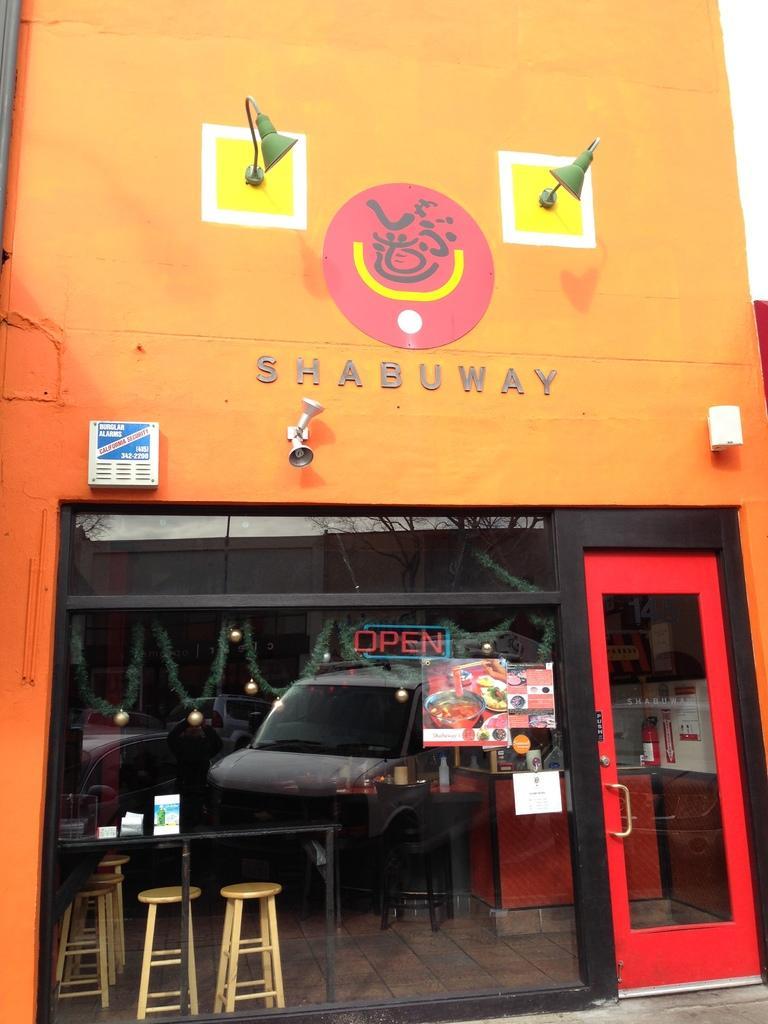Describe this image in one or two sentences. In this image in the front there is a glass and there is a door. Behind the glass there are stools, there is a table and on the table there are papers and in the background there are objects which are white and red in colour and on the glass there is the reflection of a car. On the top of the glass there is some text and there are lights. 